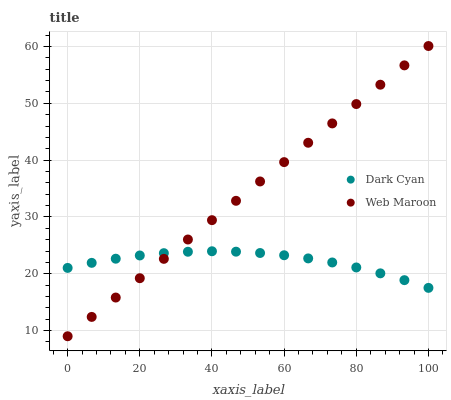Does Dark Cyan have the minimum area under the curve?
Answer yes or no. Yes. Does Web Maroon have the maximum area under the curve?
Answer yes or no. Yes. Does Web Maroon have the minimum area under the curve?
Answer yes or no. No. Is Web Maroon the smoothest?
Answer yes or no. Yes. Is Dark Cyan the roughest?
Answer yes or no. Yes. Is Web Maroon the roughest?
Answer yes or no. No. Does Web Maroon have the lowest value?
Answer yes or no. Yes. Does Web Maroon have the highest value?
Answer yes or no. Yes. Does Web Maroon intersect Dark Cyan?
Answer yes or no. Yes. Is Web Maroon less than Dark Cyan?
Answer yes or no. No. Is Web Maroon greater than Dark Cyan?
Answer yes or no. No. 